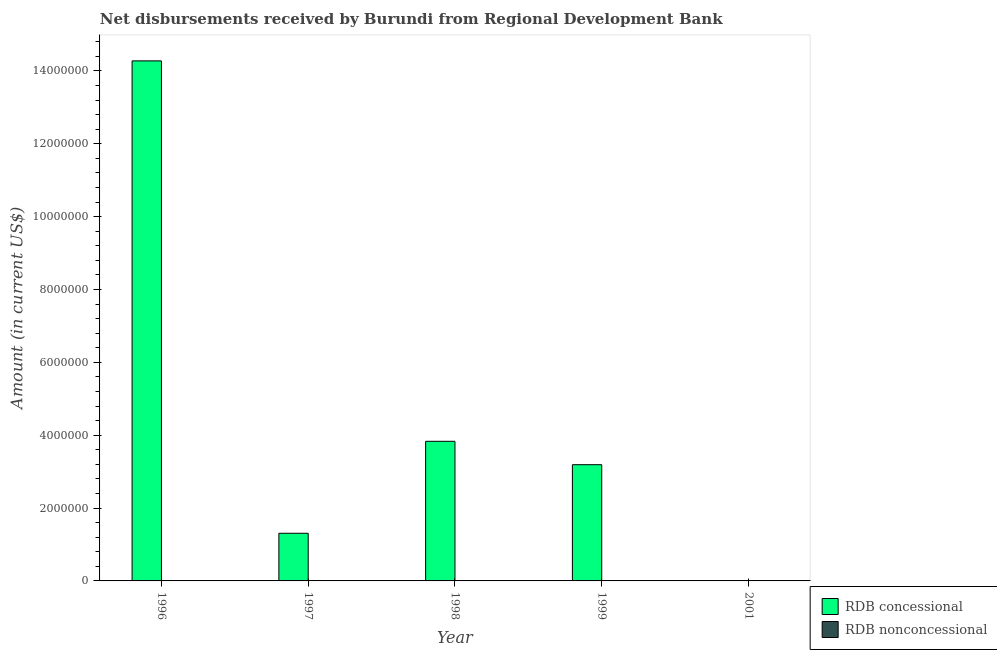Are the number of bars on each tick of the X-axis equal?
Ensure brevity in your answer.  No. How many bars are there on the 2nd tick from the left?
Make the answer very short. 1. How many bars are there on the 5th tick from the right?
Your answer should be compact. 1. What is the label of the 4th group of bars from the left?
Give a very brief answer. 1999. What is the net concessional disbursements from rdb in 1999?
Your answer should be compact. 3.19e+06. Across all years, what is the maximum net concessional disbursements from rdb?
Keep it short and to the point. 1.43e+07. Across all years, what is the minimum net concessional disbursements from rdb?
Ensure brevity in your answer.  0. In which year was the net concessional disbursements from rdb maximum?
Your response must be concise. 1996. What is the difference between the net concessional disbursements from rdb in 1997 and that in 1998?
Offer a terse response. -2.52e+06. What is the difference between the net concessional disbursements from rdb in 2001 and the net non concessional disbursements from rdb in 1998?
Give a very brief answer. -3.83e+06. What is the average net concessional disbursements from rdb per year?
Make the answer very short. 4.52e+06. What is the ratio of the net concessional disbursements from rdb in 1996 to that in 1999?
Give a very brief answer. 4.47. Is the difference between the net concessional disbursements from rdb in 1998 and 1999 greater than the difference between the net non concessional disbursements from rdb in 1998 and 1999?
Make the answer very short. No. What is the difference between the highest and the second highest net concessional disbursements from rdb?
Offer a terse response. 1.04e+07. What is the difference between the highest and the lowest net concessional disbursements from rdb?
Ensure brevity in your answer.  1.43e+07. In how many years, is the net non concessional disbursements from rdb greater than the average net non concessional disbursements from rdb taken over all years?
Offer a very short reply. 0. How many bars are there?
Make the answer very short. 4. Are all the bars in the graph horizontal?
Keep it short and to the point. No. Does the graph contain any zero values?
Your answer should be compact. Yes. Where does the legend appear in the graph?
Offer a very short reply. Bottom right. How are the legend labels stacked?
Offer a terse response. Vertical. What is the title of the graph?
Ensure brevity in your answer.  Net disbursements received by Burundi from Regional Development Bank. What is the Amount (in current US$) in RDB concessional in 1996?
Keep it short and to the point. 1.43e+07. What is the Amount (in current US$) in RDB nonconcessional in 1996?
Offer a terse response. 0. What is the Amount (in current US$) in RDB concessional in 1997?
Offer a very short reply. 1.31e+06. What is the Amount (in current US$) of RDB concessional in 1998?
Keep it short and to the point. 3.83e+06. What is the Amount (in current US$) of RDB concessional in 1999?
Your answer should be very brief. 3.19e+06. What is the Amount (in current US$) in RDB concessional in 2001?
Your response must be concise. 0. Across all years, what is the maximum Amount (in current US$) in RDB concessional?
Keep it short and to the point. 1.43e+07. What is the total Amount (in current US$) of RDB concessional in the graph?
Provide a succinct answer. 2.26e+07. What is the total Amount (in current US$) in RDB nonconcessional in the graph?
Offer a terse response. 0. What is the difference between the Amount (in current US$) of RDB concessional in 1996 and that in 1997?
Your answer should be compact. 1.30e+07. What is the difference between the Amount (in current US$) of RDB concessional in 1996 and that in 1998?
Ensure brevity in your answer.  1.04e+07. What is the difference between the Amount (in current US$) in RDB concessional in 1996 and that in 1999?
Ensure brevity in your answer.  1.11e+07. What is the difference between the Amount (in current US$) in RDB concessional in 1997 and that in 1998?
Your answer should be compact. -2.52e+06. What is the difference between the Amount (in current US$) in RDB concessional in 1997 and that in 1999?
Keep it short and to the point. -1.88e+06. What is the difference between the Amount (in current US$) in RDB concessional in 1998 and that in 1999?
Offer a terse response. 6.42e+05. What is the average Amount (in current US$) in RDB concessional per year?
Provide a succinct answer. 4.52e+06. What is the average Amount (in current US$) of RDB nonconcessional per year?
Offer a very short reply. 0. What is the ratio of the Amount (in current US$) of RDB concessional in 1996 to that in 1997?
Offer a very short reply. 10.92. What is the ratio of the Amount (in current US$) of RDB concessional in 1996 to that in 1998?
Offer a terse response. 3.72. What is the ratio of the Amount (in current US$) in RDB concessional in 1996 to that in 1999?
Offer a terse response. 4.47. What is the ratio of the Amount (in current US$) of RDB concessional in 1997 to that in 1998?
Your answer should be very brief. 0.34. What is the ratio of the Amount (in current US$) of RDB concessional in 1997 to that in 1999?
Ensure brevity in your answer.  0.41. What is the ratio of the Amount (in current US$) of RDB concessional in 1998 to that in 1999?
Your response must be concise. 1.2. What is the difference between the highest and the second highest Amount (in current US$) of RDB concessional?
Your response must be concise. 1.04e+07. What is the difference between the highest and the lowest Amount (in current US$) of RDB concessional?
Ensure brevity in your answer.  1.43e+07. 